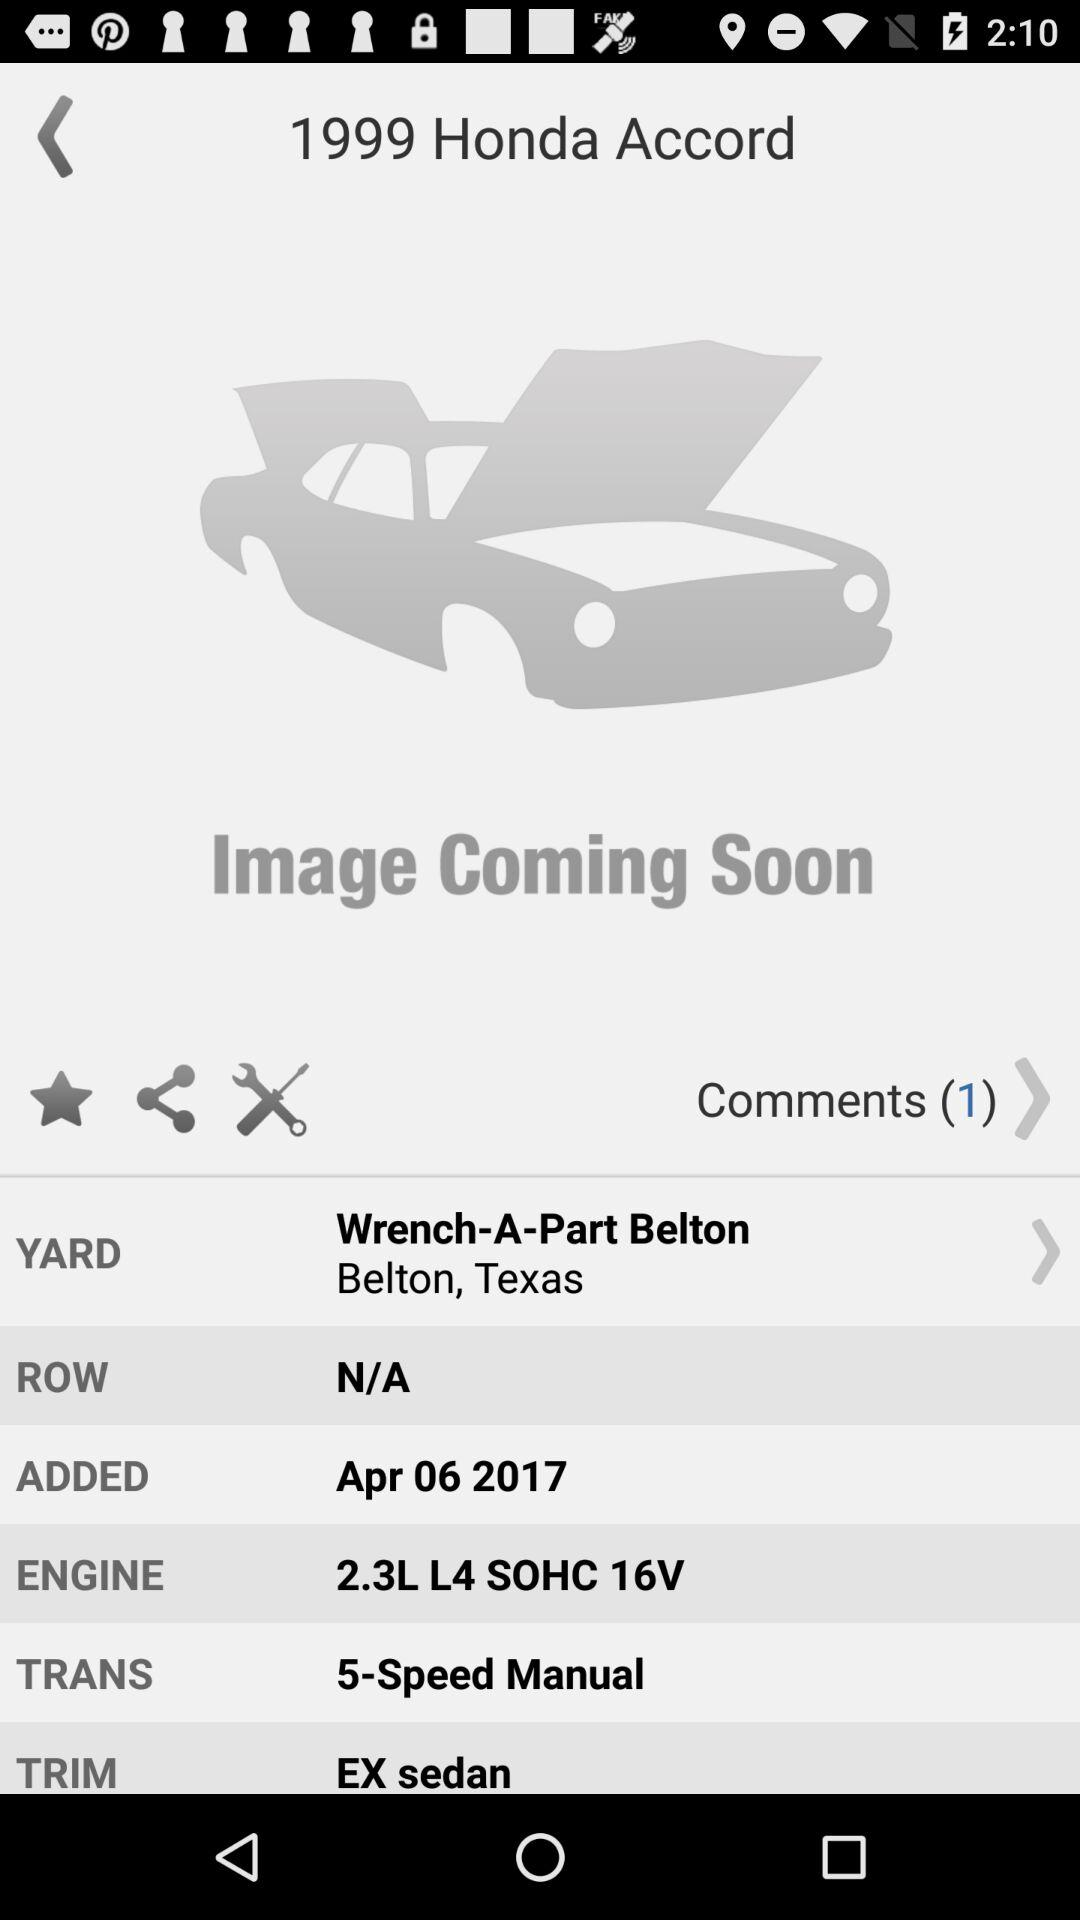What is the year of the vehicle? 1999 